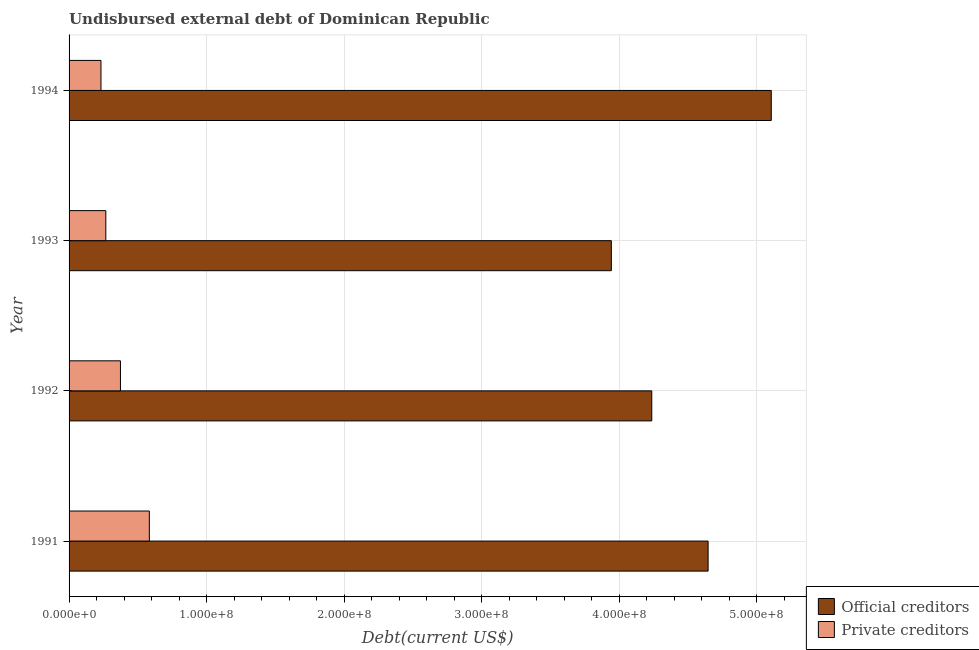How many groups of bars are there?
Offer a very short reply. 4. Are the number of bars per tick equal to the number of legend labels?
Offer a very short reply. Yes. Are the number of bars on each tick of the Y-axis equal?
Keep it short and to the point. Yes. How many bars are there on the 3rd tick from the top?
Provide a succinct answer. 2. What is the undisbursed external debt of private creditors in 1992?
Ensure brevity in your answer.  3.73e+07. Across all years, what is the maximum undisbursed external debt of private creditors?
Your answer should be very brief. 5.83e+07. Across all years, what is the minimum undisbursed external debt of official creditors?
Provide a short and direct response. 3.94e+08. What is the total undisbursed external debt of private creditors in the graph?
Make the answer very short. 1.46e+08. What is the difference between the undisbursed external debt of private creditors in 1991 and that in 1994?
Your answer should be very brief. 3.52e+07. What is the difference between the undisbursed external debt of private creditors in 1994 and the undisbursed external debt of official creditors in 1993?
Ensure brevity in your answer.  -3.71e+08. What is the average undisbursed external debt of official creditors per year?
Your answer should be compact. 4.48e+08. In the year 1994, what is the difference between the undisbursed external debt of official creditors and undisbursed external debt of private creditors?
Give a very brief answer. 4.87e+08. What is the ratio of the undisbursed external debt of private creditors in 1991 to that in 1993?
Ensure brevity in your answer.  2.18. Is the undisbursed external debt of official creditors in 1992 less than that in 1994?
Your answer should be compact. Yes. What is the difference between the highest and the second highest undisbursed external debt of private creditors?
Provide a succinct answer. 2.10e+07. What is the difference between the highest and the lowest undisbursed external debt of private creditors?
Provide a short and direct response. 3.52e+07. What does the 1st bar from the top in 1993 represents?
Keep it short and to the point. Private creditors. What does the 1st bar from the bottom in 1992 represents?
Offer a very short reply. Official creditors. Are the values on the major ticks of X-axis written in scientific E-notation?
Ensure brevity in your answer.  Yes. Does the graph contain any zero values?
Keep it short and to the point. No. Does the graph contain grids?
Your answer should be compact. Yes. Where does the legend appear in the graph?
Offer a terse response. Bottom right. How many legend labels are there?
Ensure brevity in your answer.  2. What is the title of the graph?
Your answer should be very brief. Undisbursed external debt of Dominican Republic. Does "Central government" appear as one of the legend labels in the graph?
Keep it short and to the point. No. What is the label or title of the X-axis?
Offer a very short reply. Debt(current US$). What is the label or title of the Y-axis?
Your answer should be compact. Year. What is the Debt(current US$) of Official creditors in 1991?
Give a very brief answer. 4.64e+08. What is the Debt(current US$) of Private creditors in 1991?
Your answer should be compact. 5.83e+07. What is the Debt(current US$) in Official creditors in 1992?
Your answer should be very brief. 4.24e+08. What is the Debt(current US$) of Private creditors in 1992?
Make the answer very short. 3.73e+07. What is the Debt(current US$) in Official creditors in 1993?
Your answer should be very brief. 3.94e+08. What is the Debt(current US$) in Private creditors in 1993?
Offer a very short reply. 2.67e+07. What is the Debt(current US$) of Official creditors in 1994?
Provide a short and direct response. 5.10e+08. What is the Debt(current US$) of Private creditors in 1994?
Make the answer very short. 2.32e+07. Across all years, what is the maximum Debt(current US$) in Official creditors?
Your answer should be very brief. 5.10e+08. Across all years, what is the maximum Debt(current US$) of Private creditors?
Offer a terse response. 5.83e+07. Across all years, what is the minimum Debt(current US$) of Official creditors?
Provide a short and direct response. 3.94e+08. Across all years, what is the minimum Debt(current US$) of Private creditors?
Provide a succinct answer. 2.32e+07. What is the total Debt(current US$) of Official creditors in the graph?
Provide a short and direct response. 1.79e+09. What is the total Debt(current US$) of Private creditors in the graph?
Your answer should be very brief. 1.46e+08. What is the difference between the Debt(current US$) of Official creditors in 1991 and that in 1992?
Offer a terse response. 4.10e+07. What is the difference between the Debt(current US$) in Private creditors in 1991 and that in 1992?
Your answer should be compact. 2.10e+07. What is the difference between the Debt(current US$) of Official creditors in 1991 and that in 1993?
Offer a very short reply. 7.03e+07. What is the difference between the Debt(current US$) of Private creditors in 1991 and that in 1993?
Make the answer very short. 3.16e+07. What is the difference between the Debt(current US$) in Official creditors in 1991 and that in 1994?
Offer a very short reply. -4.59e+07. What is the difference between the Debt(current US$) in Private creditors in 1991 and that in 1994?
Offer a terse response. 3.52e+07. What is the difference between the Debt(current US$) of Official creditors in 1992 and that in 1993?
Your answer should be very brief. 2.94e+07. What is the difference between the Debt(current US$) in Private creditors in 1992 and that in 1993?
Provide a short and direct response. 1.06e+07. What is the difference between the Debt(current US$) of Official creditors in 1992 and that in 1994?
Offer a terse response. -8.69e+07. What is the difference between the Debt(current US$) of Private creditors in 1992 and that in 1994?
Give a very brief answer. 1.42e+07. What is the difference between the Debt(current US$) of Official creditors in 1993 and that in 1994?
Offer a terse response. -1.16e+08. What is the difference between the Debt(current US$) in Private creditors in 1993 and that in 1994?
Give a very brief answer. 3.52e+06. What is the difference between the Debt(current US$) in Official creditors in 1991 and the Debt(current US$) in Private creditors in 1992?
Your response must be concise. 4.27e+08. What is the difference between the Debt(current US$) in Official creditors in 1991 and the Debt(current US$) in Private creditors in 1993?
Offer a very short reply. 4.38e+08. What is the difference between the Debt(current US$) in Official creditors in 1991 and the Debt(current US$) in Private creditors in 1994?
Your answer should be very brief. 4.41e+08. What is the difference between the Debt(current US$) of Official creditors in 1992 and the Debt(current US$) of Private creditors in 1993?
Offer a terse response. 3.97e+08. What is the difference between the Debt(current US$) in Official creditors in 1992 and the Debt(current US$) in Private creditors in 1994?
Your answer should be compact. 4.00e+08. What is the difference between the Debt(current US$) of Official creditors in 1993 and the Debt(current US$) of Private creditors in 1994?
Offer a very short reply. 3.71e+08. What is the average Debt(current US$) in Official creditors per year?
Offer a very short reply. 4.48e+08. What is the average Debt(current US$) in Private creditors per year?
Ensure brevity in your answer.  3.64e+07. In the year 1991, what is the difference between the Debt(current US$) of Official creditors and Debt(current US$) of Private creditors?
Provide a succinct answer. 4.06e+08. In the year 1992, what is the difference between the Debt(current US$) of Official creditors and Debt(current US$) of Private creditors?
Offer a very short reply. 3.86e+08. In the year 1993, what is the difference between the Debt(current US$) in Official creditors and Debt(current US$) in Private creditors?
Ensure brevity in your answer.  3.67e+08. In the year 1994, what is the difference between the Debt(current US$) of Official creditors and Debt(current US$) of Private creditors?
Your answer should be compact. 4.87e+08. What is the ratio of the Debt(current US$) of Official creditors in 1991 to that in 1992?
Give a very brief answer. 1.1. What is the ratio of the Debt(current US$) of Private creditors in 1991 to that in 1992?
Provide a short and direct response. 1.56. What is the ratio of the Debt(current US$) in Official creditors in 1991 to that in 1993?
Your answer should be compact. 1.18. What is the ratio of the Debt(current US$) of Private creditors in 1991 to that in 1993?
Your response must be concise. 2.18. What is the ratio of the Debt(current US$) in Official creditors in 1991 to that in 1994?
Your answer should be very brief. 0.91. What is the ratio of the Debt(current US$) in Private creditors in 1991 to that in 1994?
Give a very brief answer. 2.52. What is the ratio of the Debt(current US$) in Official creditors in 1992 to that in 1993?
Ensure brevity in your answer.  1.07. What is the ratio of the Debt(current US$) of Private creditors in 1992 to that in 1993?
Make the answer very short. 1.4. What is the ratio of the Debt(current US$) in Official creditors in 1992 to that in 1994?
Your response must be concise. 0.83. What is the ratio of the Debt(current US$) of Private creditors in 1992 to that in 1994?
Offer a very short reply. 1.61. What is the ratio of the Debt(current US$) in Official creditors in 1993 to that in 1994?
Your answer should be very brief. 0.77. What is the ratio of the Debt(current US$) in Private creditors in 1993 to that in 1994?
Make the answer very short. 1.15. What is the difference between the highest and the second highest Debt(current US$) of Official creditors?
Provide a short and direct response. 4.59e+07. What is the difference between the highest and the second highest Debt(current US$) in Private creditors?
Provide a succinct answer. 2.10e+07. What is the difference between the highest and the lowest Debt(current US$) of Official creditors?
Your answer should be compact. 1.16e+08. What is the difference between the highest and the lowest Debt(current US$) of Private creditors?
Your answer should be very brief. 3.52e+07. 